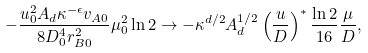<formula> <loc_0><loc_0><loc_500><loc_500>- \frac { u _ { 0 } ^ { 2 } A _ { d } \kappa ^ { - \epsilon } v _ { A 0 } } { 8 D _ { 0 } ^ { 4 } r _ { B 0 } ^ { 2 } } \mu _ { 0 } ^ { 2 } \ln 2 \rightarrow - \kappa ^ { d / 2 } A _ { d } ^ { 1 / 2 } \left ( \frac { u } { D } \right ) ^ { * } \frac { \ln 2 } { 1 6 } \frac { \mu } { D } ,</formula> 